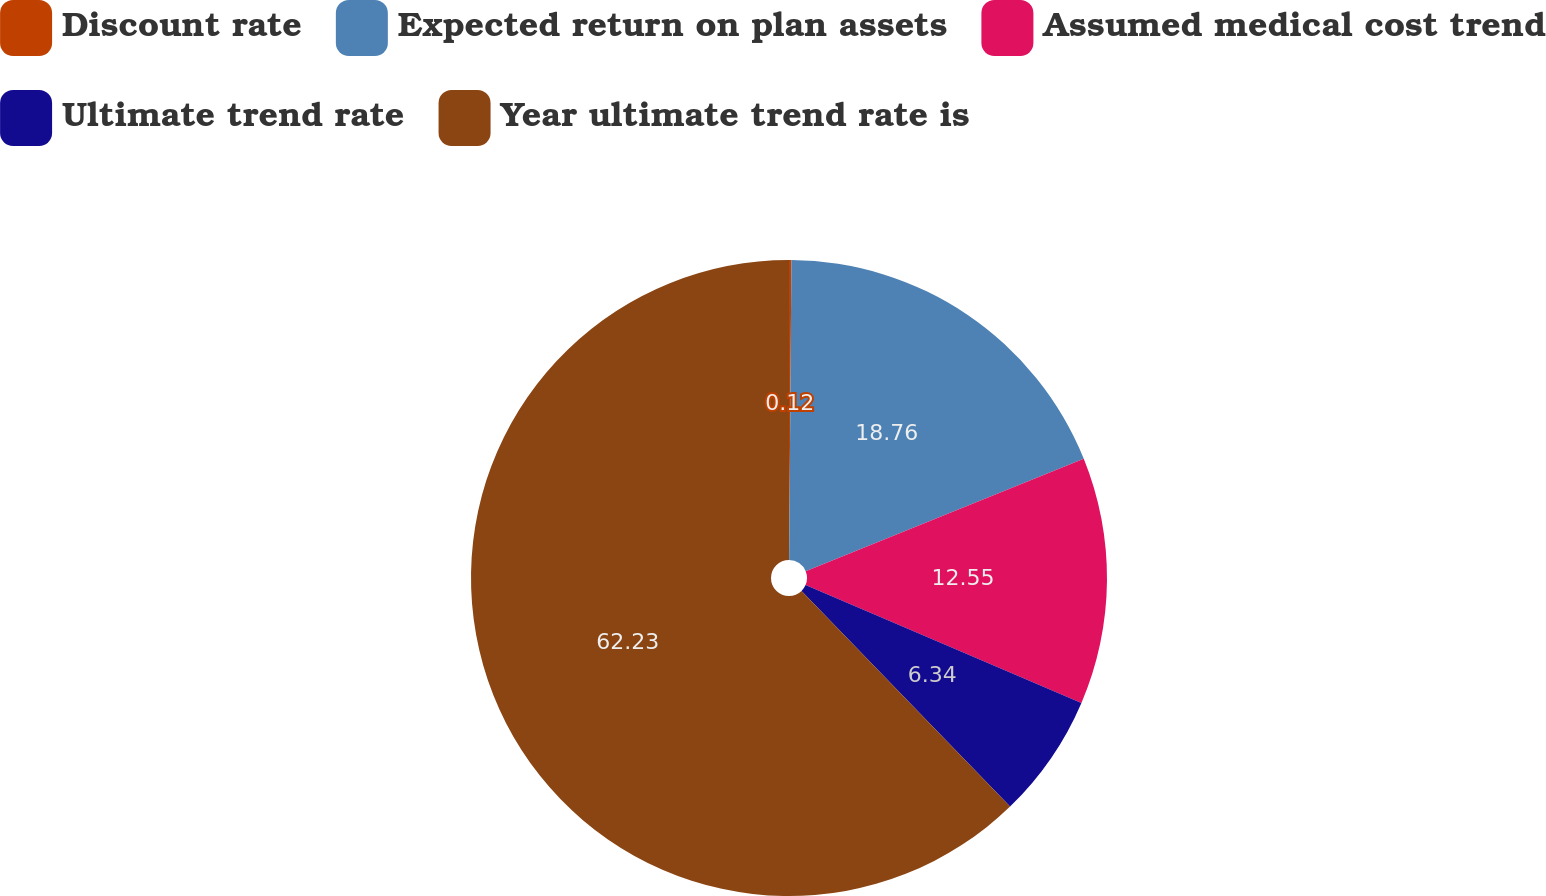<chart> <loc_0><loc_0><loc_500><loc_500><pie_chart><fcel>Discount rate<fcel>Expected return on plan assets<fcel>Assumed medical cost trend<fcel>Ultimate trend rate<fcel>Year ultimate trend rate is<nl><fcel>0.12%<fcel>18.76%<fcel>12.55%<fcel>6.34%<fcel>62.24%<nl></chart> 